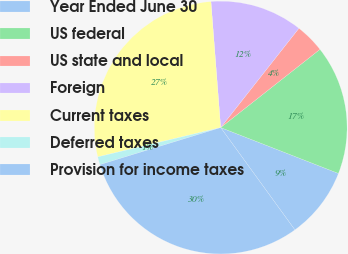Convert chart. <chart><loc_0><loc_0><loc_500><loc_500><pie_chart><fcel>Year Ended June 30<fcel>US federal<fcel>US state and local<fcel>Foreign<fcel>Current taxes<fcel>Deferred taxes<fcel>Provision for income taxes<nl><fcel>9.1%<fcel>16.53%<fcel>3.76%<fcel>11.85%<fcel>27.5%<fcel>1.01%<fcel>30.25%<nl></chart> 